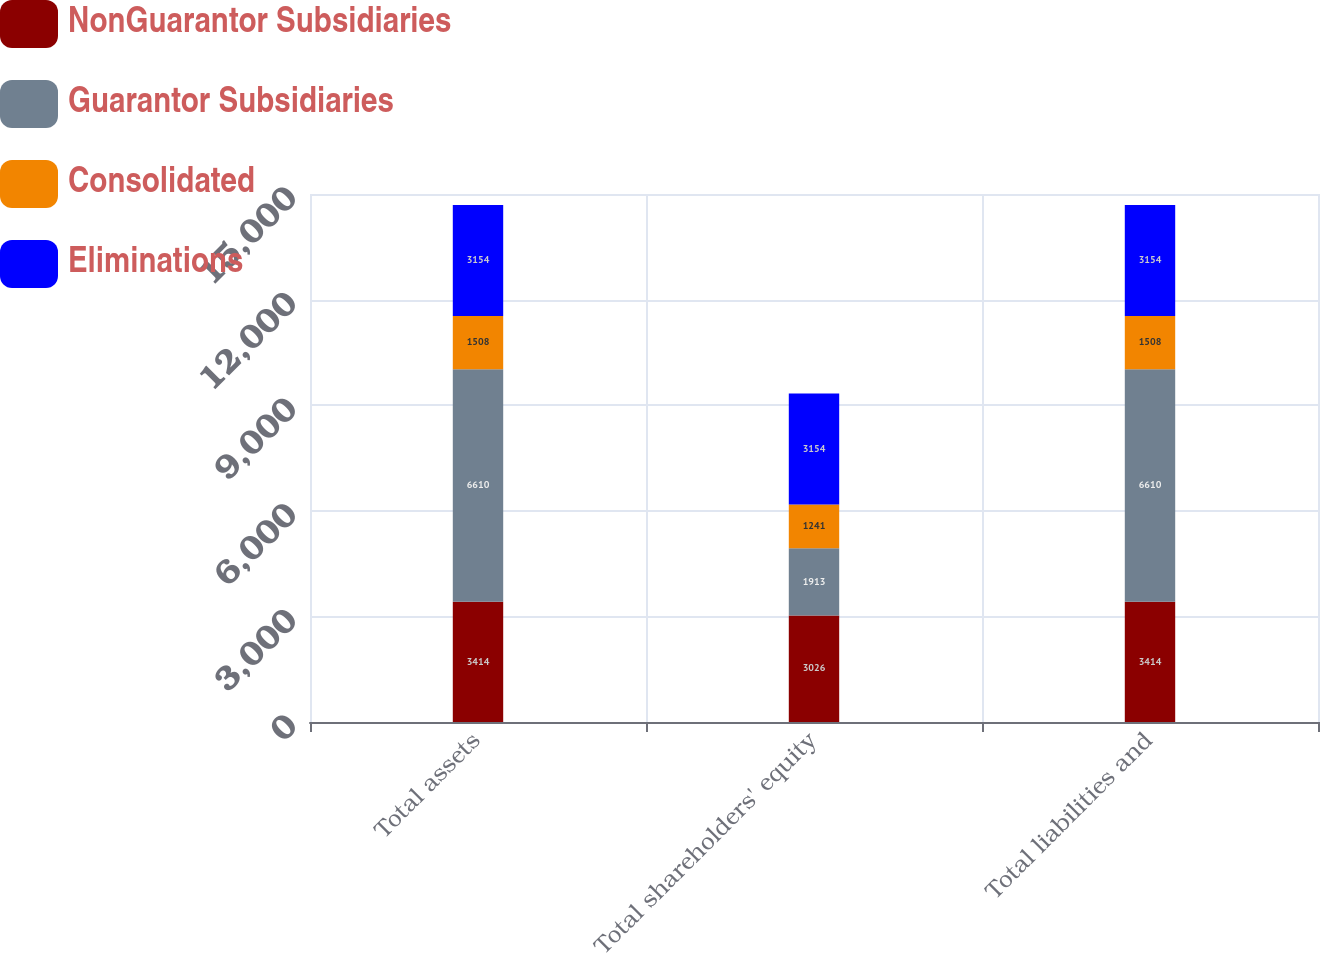Convert chart. <chart><loc_0><loc_0><loc_500><loc_500><stacked_bar_chart><ecel><fcel>Total assets<fcel>Total shareholders' equity<fcel>Total liabilities and<nl><fcel>NonGuarantor Subsidiaries<fcel>3414<fcel>3026<fcel>3414<nl><fcel>Guarantor Subsidiaries<fcel>6610<fcel>1913<fcel>6610<nl><fcel>Consolidated<fcel>1508<fcel>1241<fcel>1508<nl><fcel>Eliminations<fcel>3154<fcel>3154<fcel>3154<nl></chart> 